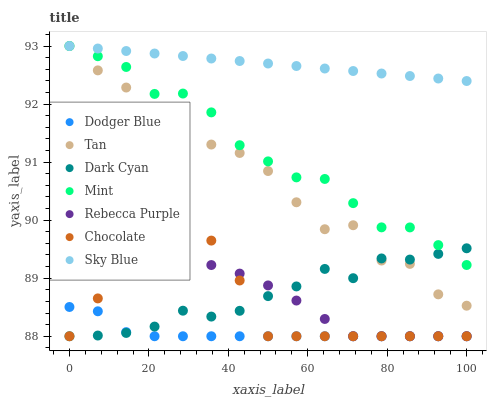Does Dodger Blue have the minimum area under the curve?
Answer yes or no. Yes. Does Sky Blue have the maximum area under the curve?
Answer yes or no. Yes. Does Rebecca Purple have the minimum area under the curve?
Answer yes or no. No. Does Rebecca Purple have the maximum area under the curve?
Answer yes or no. No. Is Sky Blue the smoothest?
Answer yes or no. Yes. Is Tan the roughest?
Answer yes or no. Yes. Is Dodger Blue the smoothest?
Answer yes or no. No. Is Dodger Blue the roughest?
Answer yes or no. No. Does Chocolate have the lowest value?
Answer yes or no. Yes. Does Sky Blue have the lowest value?
Answer yes or no. No. Does Mint have the highest value?
Answer yes or no. Yes. Does Rebecca Purple have the highest value?
Answer yes or no. No. Is Dodger Blue less than Sky Blue?
Answer yes or no. Yes. Is Tan greater than Rebecca Purple?
Answer yes or no. Yes. Does Rebecca Purple intersect Dodger Blue?
Answer yes or no. Yes. Is Rebecca Purple less than Dodger Blue?
Answer yes or no. No. Is Rebecca Purple greater than Dodger Blue?
Answer yes or no. No. Does Dodger Blue intersect Sky Blue?
Answer yes or no. No. 